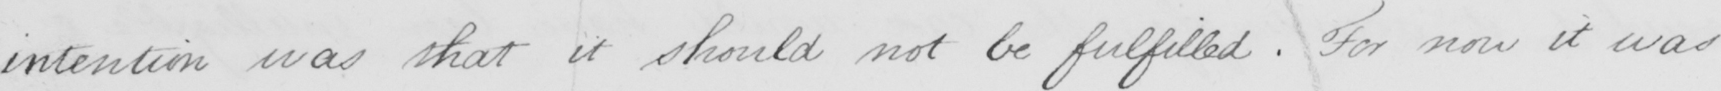Please provide the text content of this handwritten line. intention was that it should not be fulfilled . For now it was 